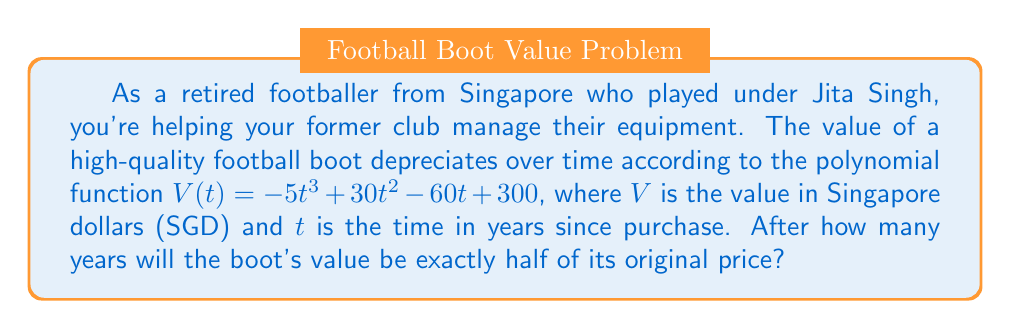Could you help me with this problem? To solve this problem, we need to follow these steps:

1) First, let's identify the original price of the boot. This is the value when $t = 0$:
   $V(0) = -5(0)^3 + 30(0)^2 - 60(0) + 300 = 300$ SGD

2) We want to find when the value is half of this, which is 150 SGD.

3) So, we need to solve the equation:
   $-5t^3 + 30t^2 - 60t + 300 = 150$

4) Rearranging the equation:
   $-5t^3 + 30t^2 - 60t + 150 = 0$

5) This is a cubic equation. While there are methods to solve cubic equations analytically, it's often easier to use numerical methods or graphing.

6) Using a graphing calculator or computer algebra system, we can find that this equation has three roots: approximately 1.77, 3.41, and 5.82.

7) Since we're dealing with time since purchase, negative values don't make sense, and we're likely interested in the first time the value drops to half. Therefore, the answer is approximately 1.77 years.

8) To verify, we can plug this value back into our original function:
   $V(1.77) ≈ -5(1.77)^3 + 30(1.77)^2 - 60(1.77) + 300 ≈ 150$ SGD
Answer: The boot's value will be exactly half of its original price after approximately 1.77 years. 